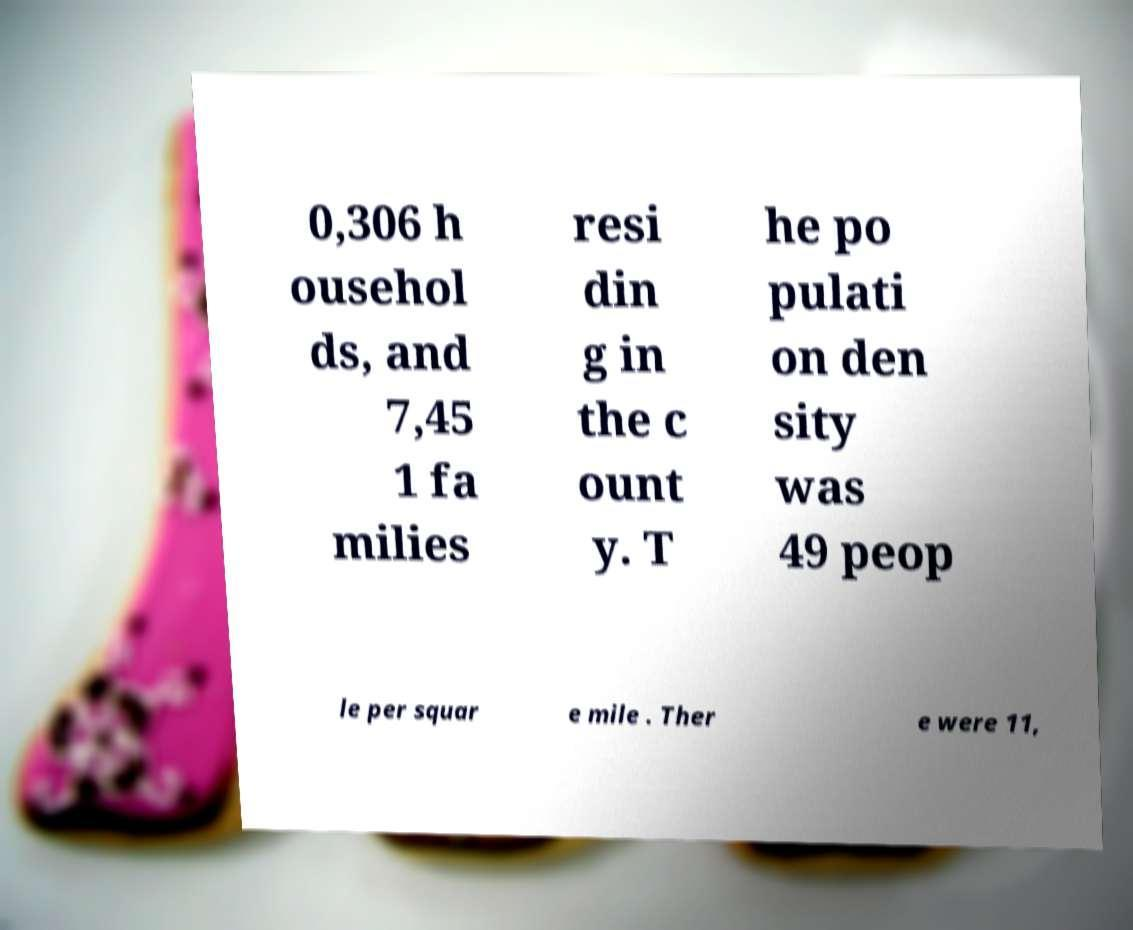For documentation purposes, I need the text within this image transcribed. Could you provide that? 0,306 h ousehol ds, and 7,45 1 fa milies resi din g in the c ount y. T he po pulati on den sity was 49 peop le per squar e mile . Ther e were 11, 